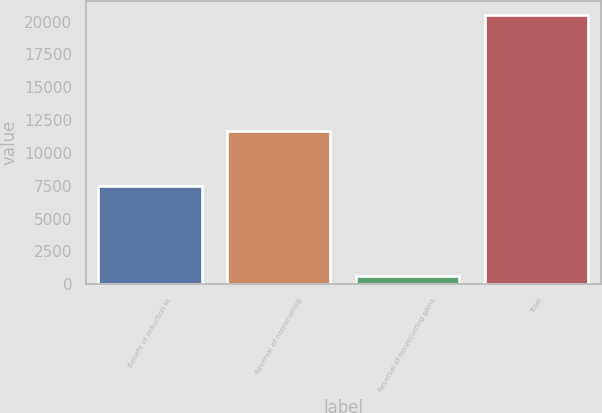<chart> <loc_0><loc_0><loc_500><loc_500><bar_chart><fcel>Benefit of reduction in<fcel>Reversal of nonrecurring<fcel>Reversal of nonrecurring gains<fcel>Total<nl><fcel>7505<fcel>11654<fcel>612<fcel>20516<nl></chart> 